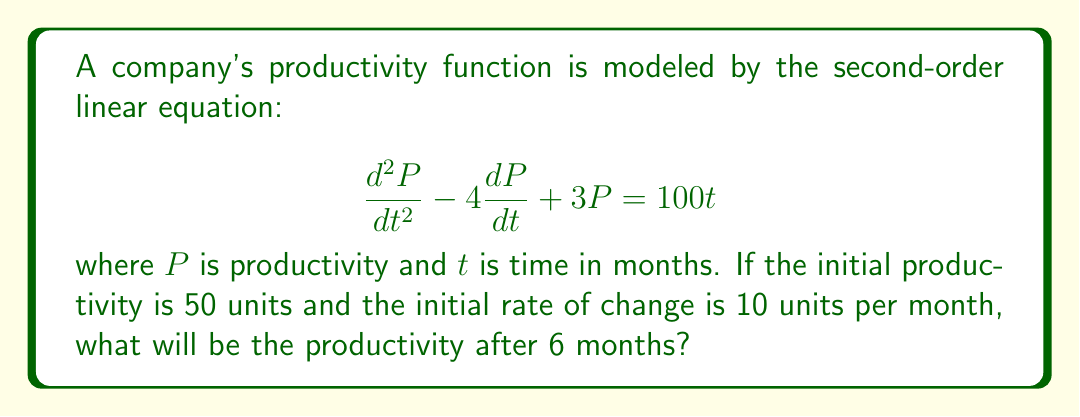Help me with this question. To solve this problem, we need to follow these steps:

1) The general solution to this second-order linear equation is the sum of the complementary function and the particular integral.

2) For the complementary function, we solve the characteristic equation:
   $$r^2 - 4r + 3 = 0$$
   $$(r - 1)(r - 3) = 0$$
   So, $r = 1$ or $r = 3$

   The complementary function is thus:
   $$P_c = Ae^t + Be^{3t}$$

3) For the particular integral, we assume a solution of the form:
   $$P_p = at + b$$
   
   Substituting this into the original equation:
   $$0 - 4a + 3(at + b) = 100t$$
   $$3at + 3b - 4a = 100t$$

   Equating coefficients:
   $$3a = 100$$
   $$a = \frac{100}{3}$$
   $$3b - 4a = 0$$
   $$3b - 4(\frac{100}{3}) = 0$$
   $$b = \frac{400}{9}$$

   So, the particular integral is:
   $$P_p = \frac{100}{3}t + \frac{400}{9}$$

4) The general solution is:
   $$P = Ae^t + Be^{3t} + \frac{100}{3}t + \frac{400}{9}$$

5) Using the initial conditions:
   At $t = 0$, $P = 50$:
   $$50 = A + B + \frac{400}{9}$$
   
   At $t = 0$, $\frac{dP}{dt} = 10$:
   $$10 = A + 3B + \frac{100}{3}$$

6) Solving these simultaneous equations:
   $$A = \frac{850}{9}, B = -\frac{400}{9}$$

7) Therefore, the complete solution is:
   $$P = \frac{850}{9}e^t - \frac{400}{9}e^{3t} + \frac{100}{3}t + \frac{400}{9}$$

8) To find the productivity after 6 months, we substitute $t = 6$:
   $$P(6) = \frac{850}{9}e^6 - \frac{400}{9}e^{18} + \frac{200}{3} + \frac{400}{9}$$
Answer: $P(6) = \frac{850}{9}e^6 - \frac{400}{9}e^{18} + \frac{200}{3} + \frac{400}{9} \approx 270.3$ units 